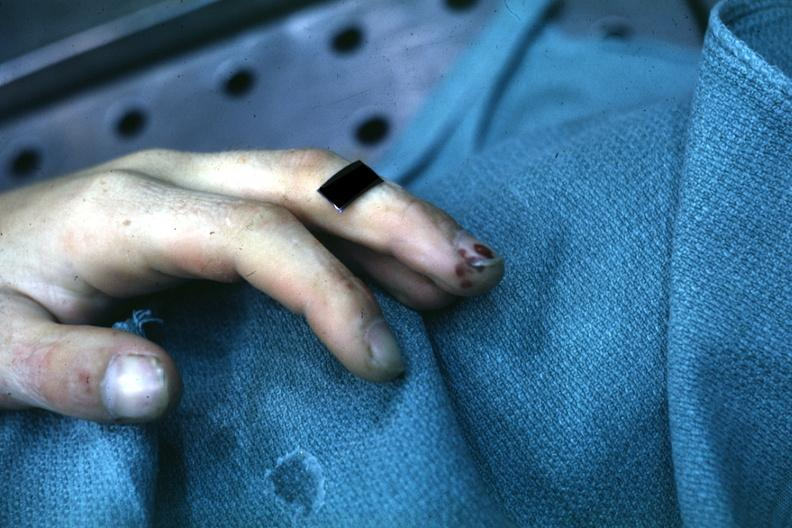does this image show lesions well shown on index finger staphylococcus?
Answer the question using a single word or phrase. Yes 